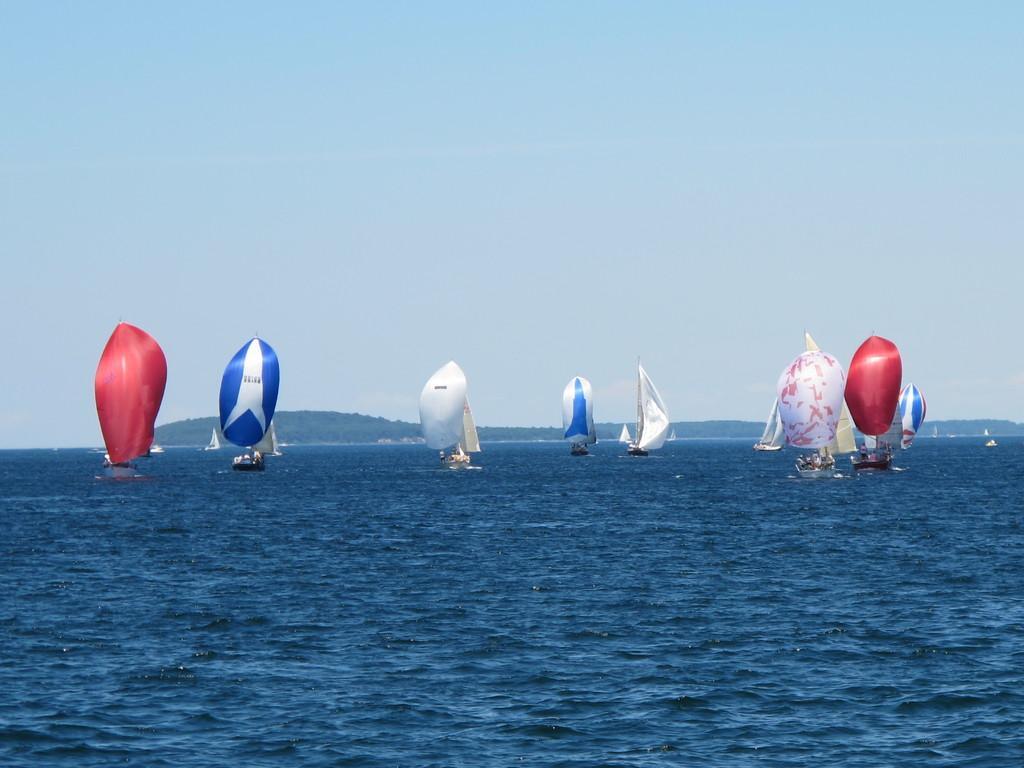Describe this image in one or two sentences. In this picture I can observe boats sailing in the ocean. I can observe different colors of sailing clothes which are in red, white and blue colors. In the background there is sky. 